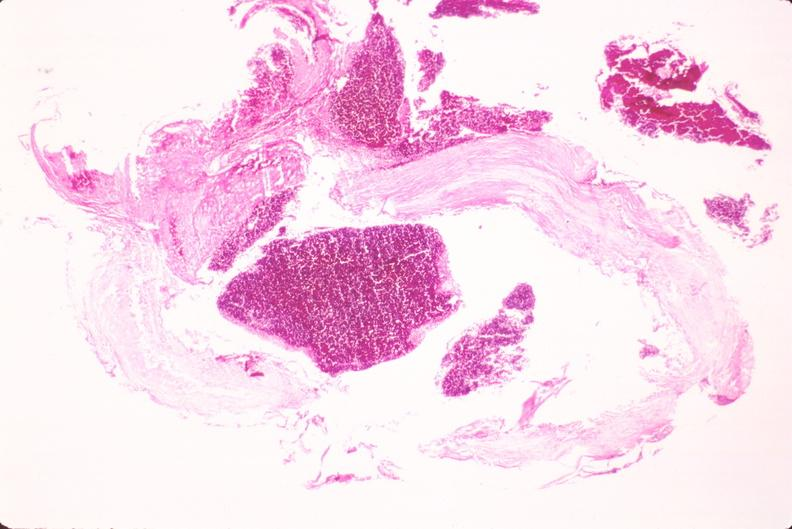s vasculature present?
Answer the question using a single word or phrase. Yes 